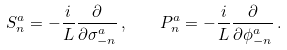Convert formula to latex. <formula><loc_0><loc_0><loc_500><loc_500>S ^ { a } _ { n } = - \frac { i } { L } \frac { \partial } { \partial \sigma ^ { a } _ { - n } } \, , \quad P ^ { a } _ { n } = - \frac { i } { L } \frac { \partial } { \partial \phi ^ { a } _ { - n } } \, .</formula> 